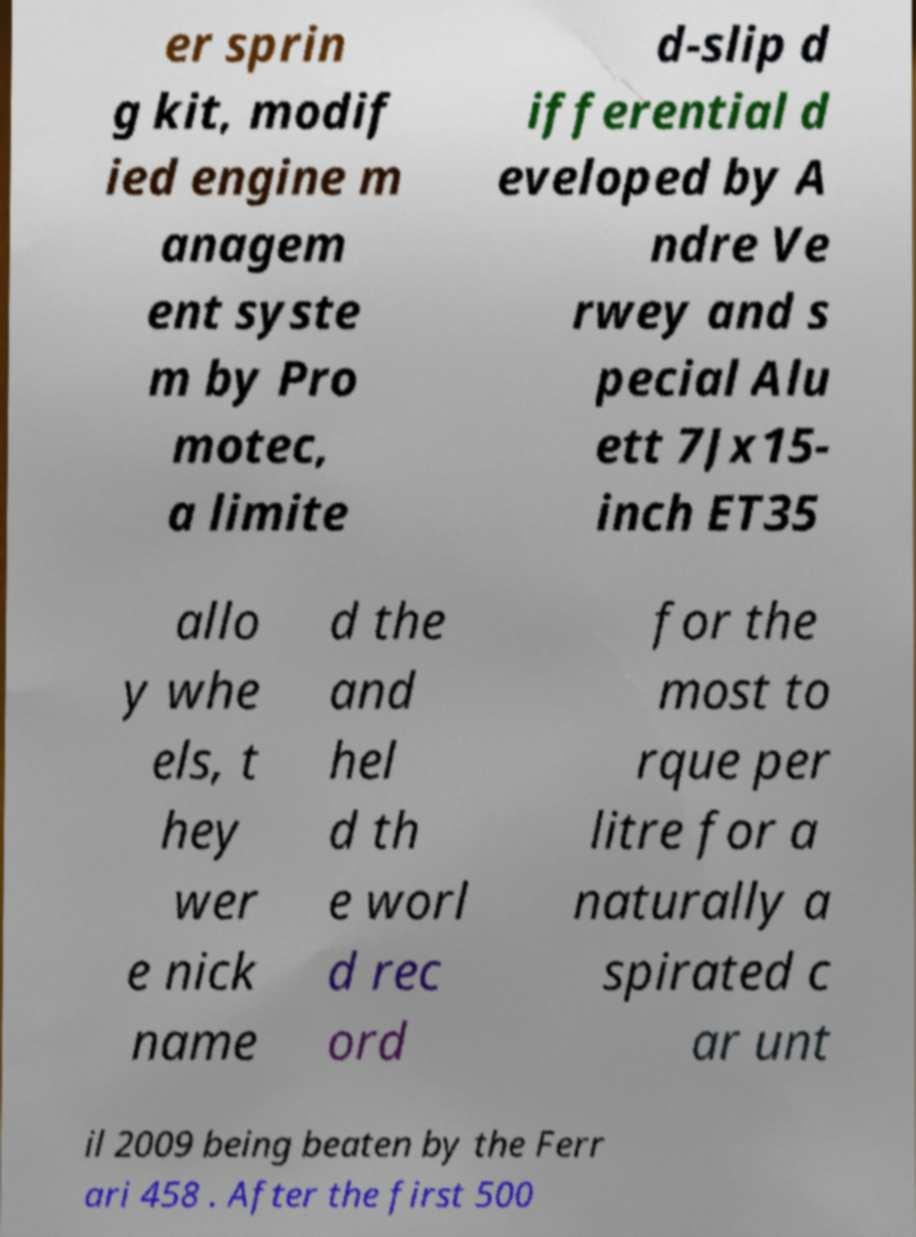Could you extract and type out the text from this image? er sprin g kit, modif ied engine m anagem ent syste m by Pro motec, a limite d-slip d ifferential d eveloped by A ndre Ve rwey and s pecial Alu ett 7Jx15- inch ET35 allo y whe els, t hey wer e nick name d the and hel d th e worl d rec ord for the most to rque per litre for a naturally a spirated c ar unt il 2009 being beaten by the Ferr ari 458 . After the first 500 